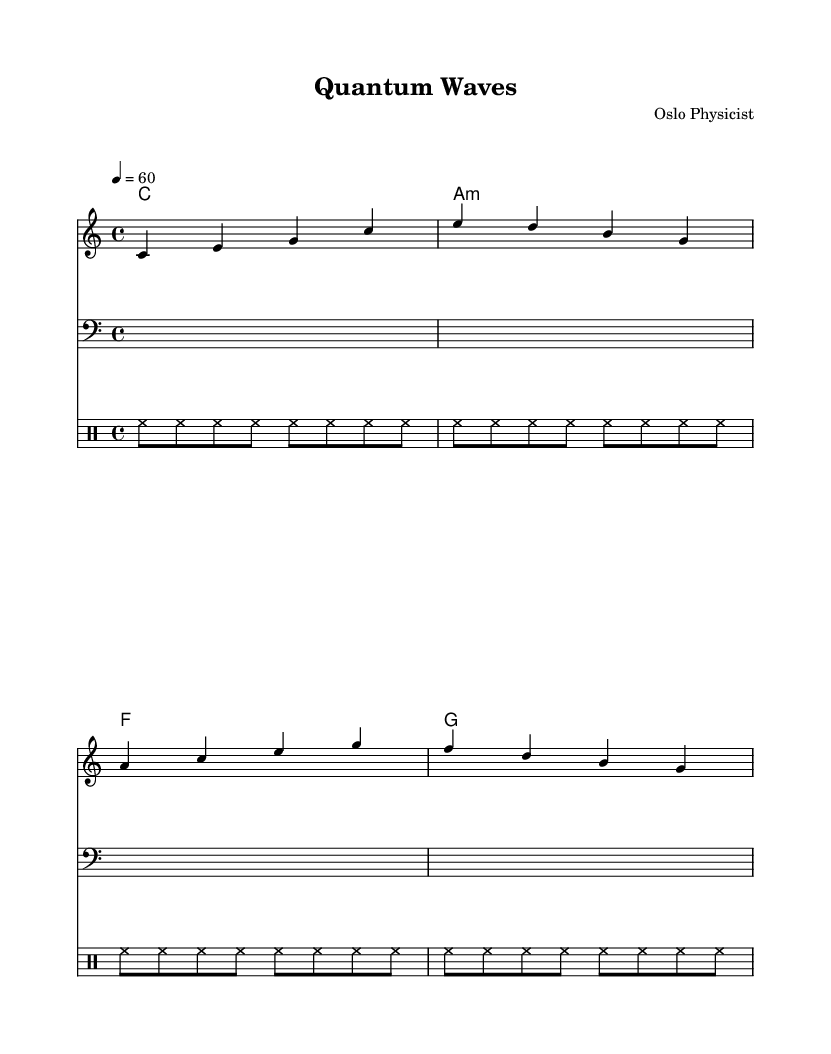What is the key signature of this music? The key signature is indicated at the beginning of the staff, where no sharps or flats are present, signifying C major.
Answer: C major What is the time signature of this music? The time signature is shown at the beginning as 4/4, which means there are four beats in a measure and a quarter note gets one beat.
Answer: 4/4 What is the tempo marking for this piece? The tempo is indicated above the staff as "4 = 60", meaning it should have 60 beats per minute, with each quarter note getting one beat.
Answer: 60 How many measures are in the main theme? Counting the groupings of notes, there are four distinct measures present in the melody of the main theme.
Answer: 4 What type of chords are used in the harmony section? The harmony section contains triads, specifically a major chord, minor chord, and the rest are major chords as indicated by their letter names.
Answer: Major and minor chords What instruments are represented in this score? The score shows three types of instruments: a melody in treble clef, a bass in the bass clef, and a drum staff beneath.
Answer: Treble, bass, drums What style of music is this sheet music representing? The style can be inferred by the ambient nature and simplicity of the melodies and harmonies, making it suitable for studying, indicating it’s ambient electronic music.
Answer: Ambient electronic music 